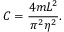Convert formula to latex. <formula><loc_0><loc_0><loc_500><loc_500>C = \frac { 4 m L ^ { 2 } } { \pi ^ { 2 } \eta ^ { 2 } } .</formula> 